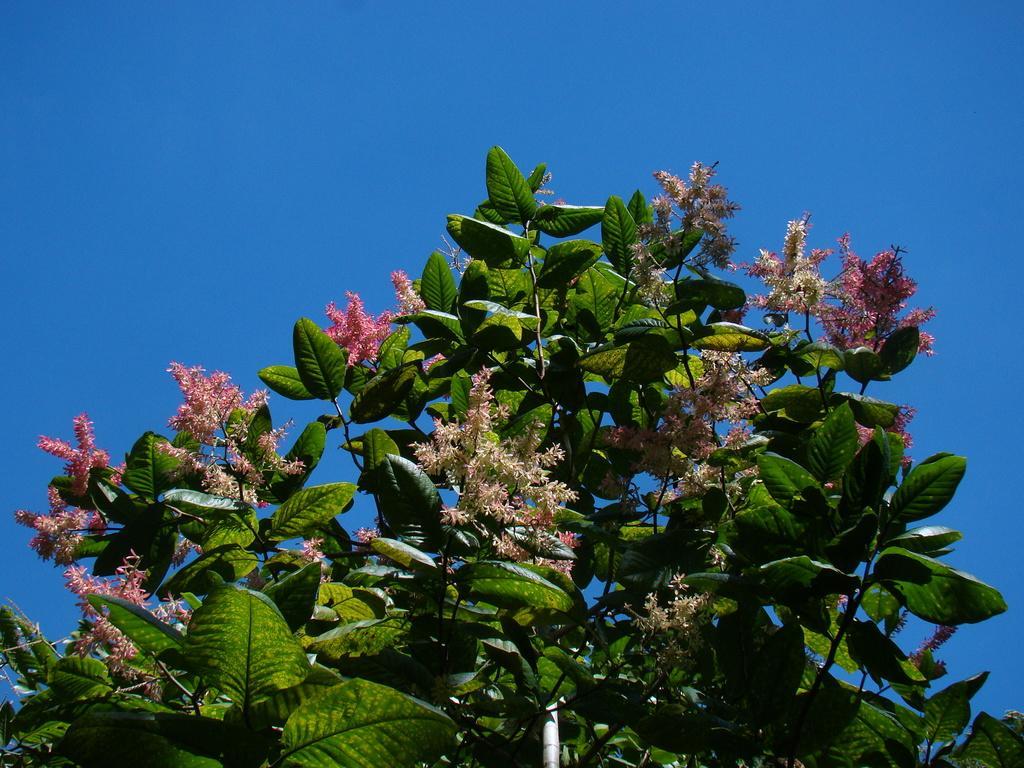Can you describe this image briefly? In this picture we can see flowers, leaves and in the background we can see the sky. 